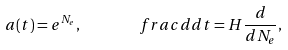<formula> <loc_0><loc_0><loc_500><loc_500>a ( t ) = e ^ { N _ { e } } , \quad \ \ \ f r a c { d } { d t } = H \frac { d } { d N _ { e } } ,</formula> 